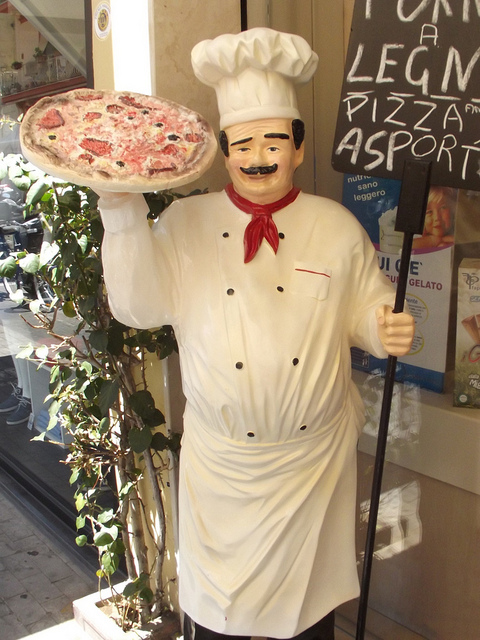What is the statue holding?
A. plunger
B. torch
C. pizza
D. television
Answer with the option's letter from the given choices directly. C 